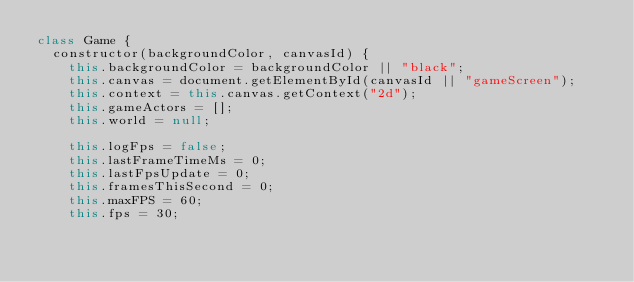Convert code to text. <code><loc_0><loc_0><loc_500><loc_500><_JavaScript_>class Game {
  constructor(backgroundColor, canvasId) {
    this.backgroundColor = backgroundColor || "black";
    this.canvas = document.getElementById(canvasId || "gameScreen");
    this.context = this.canvas.getContext("2d");
    this.gameActors = [];
    this.world = null;
    
    this.logFps = false;
    this.lastFrameTimeMs = 0;
    this.lastFpsUpdate = 0;
    this.framesThisSecond = 0;
    this.maxFPS = 60;
    this.fps = 30;</code> 